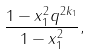Convert formula to latex. <formula><loc_0><loc_0><loc_500><loc_500>\frac { 1 - x _ { 1 } ^ { 2 } q ^ { 2 k _ { 1 } } } { 1 - x _ { 1 } ^ { 2 } } ,</formula> 